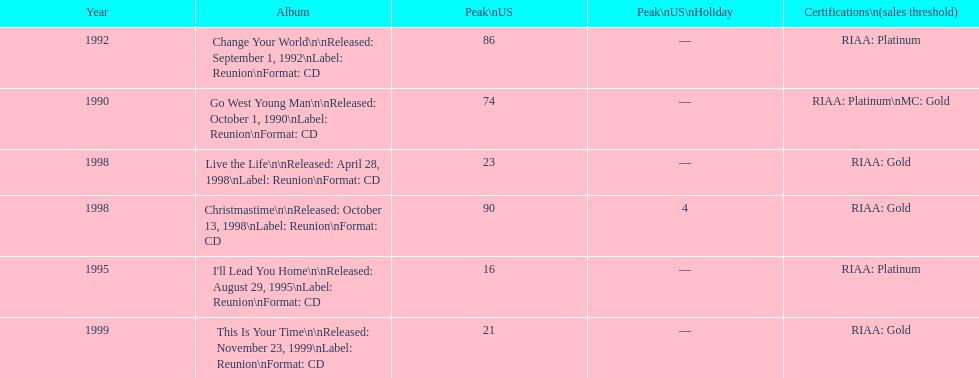Which album has the least peak in the us? I'll Lead You Home. 